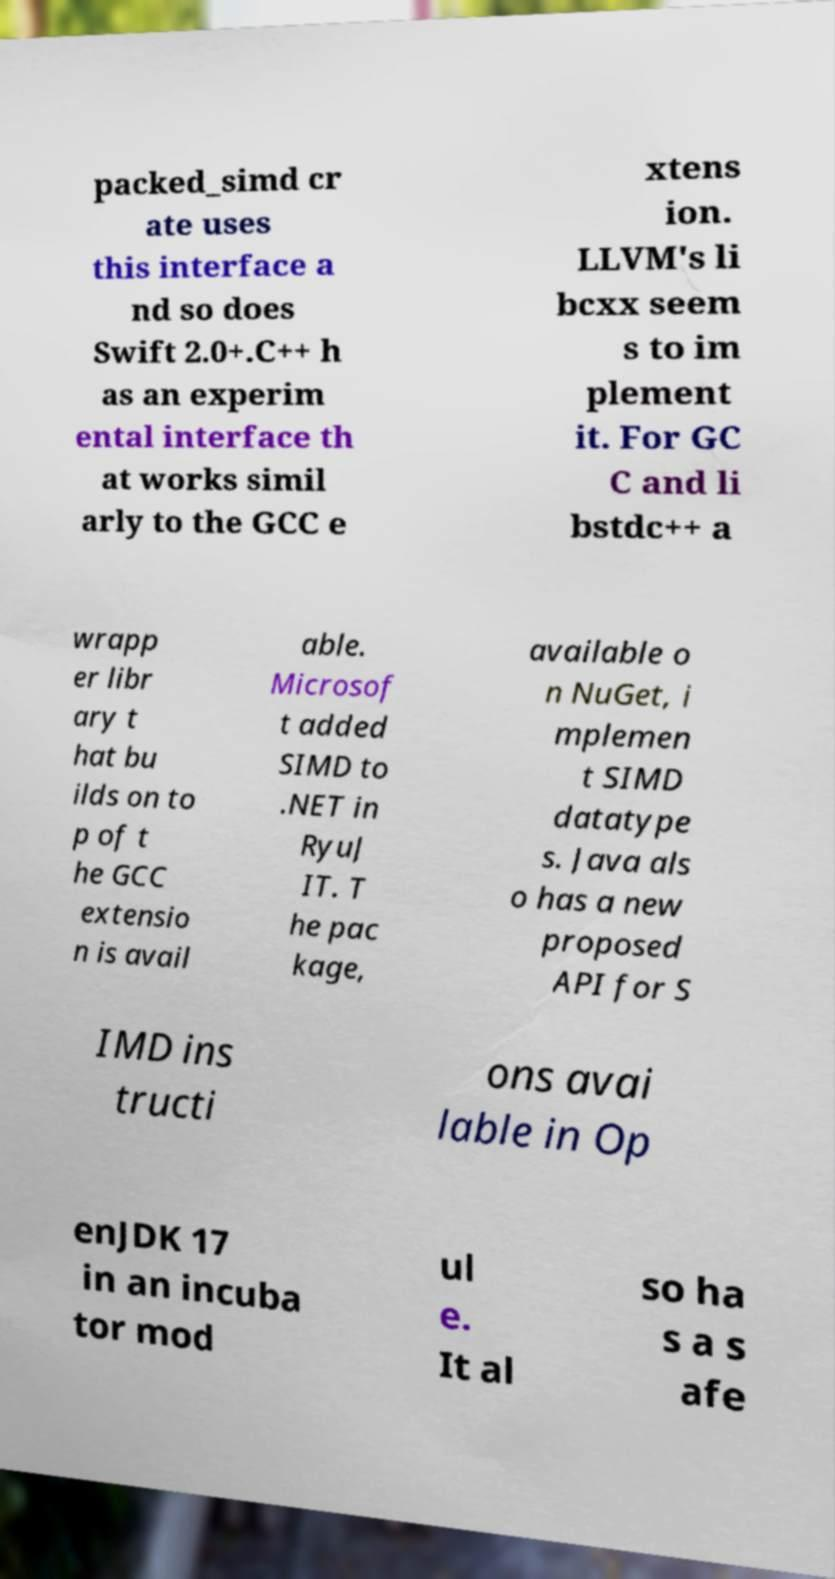Can you accurately transcribe the text from the provided image for me? packed_simd cr ate uses this interface a nd so does Swift 2.0+.C++ h as an experim ental interface th at works simil arly to the GCC e xtens ion. LLVM's li bcxx seem s to im plement it. For GC C and li bstdc++ a wrapp er libr ary t hat bu ilds on to p of t he GCC extensio n is avail able. Microsof t added SIMD to .NET in RyuJ IT. T he pac kage, available o n NuGet, i mplemen t SIMD datatype s. Java als o has a new proposed API for S IMD ins tructi ons avai lable in Op enJDK 17 in an incuba tor mod ul e. It al so ha s a s afe 